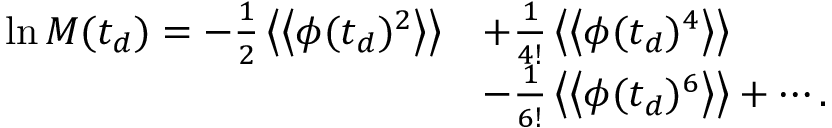<formula> <loc_0><loc_0><loc_500><loc_500>\begin{array} { r l } { \ln M ( t _ { d } ) = - \frac { 1 } { 2 } \left \langle \left \langle \phi ( t _ { d } ) ^ { 2 } \right \rangle \right \rangle } & { + \frac { 1 } { 4 ! } \left \langle \left \langle \phi ( t _ { d } ) ^ { 4 } \right \rangle \right \rangle } \\ & { - \frac { 1 } { 6 ! } \left \langle \left \langle \phi ( t _ { d } ) ^ { 6 } \right \rangle \right \rangle + \cdots . } \end{array}</formula> 